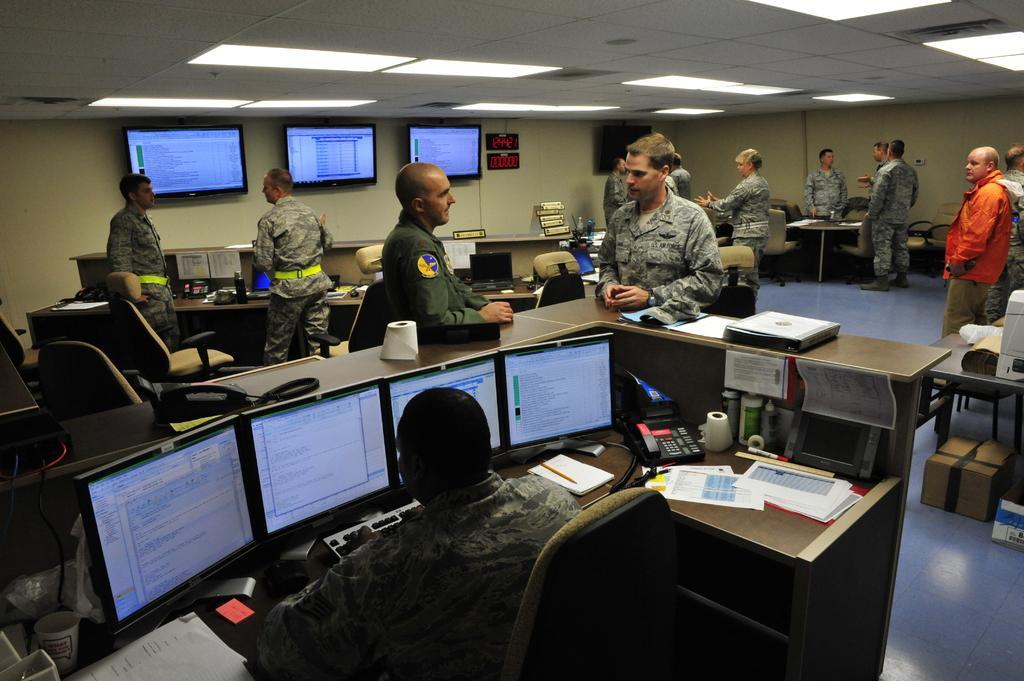Please provide a concise description of this image. There is a police officer sitting in chair and there are four systems in front of him and there are some officers standing in front of him. 